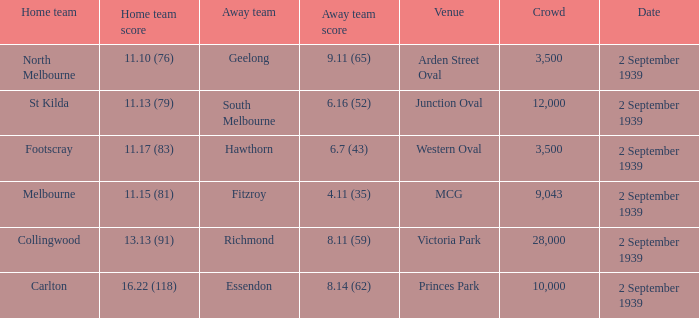Parse the full table. {'header': ['Home team', 'Home team score', 'Away team', 'Away team score', 'Venue', 'Crowd', 'Date'], 'rows': [['North Melbourne', '11.10 (76)', 'Geelong', '9.11 (65)', 'Arden Street Oval', '3,500', '2 September 1939'], ['St Kilda', '11.13 (79)', 'South Melbourne', '6.16 (52)', 'Junction Oval', '12,000', '2 September 1939'], ['Footscray', '11.17 (83)', 'Hawthorn', '6.7 (43)', 'Western Oval', '3,500', '2 September 1939'], ['Melbourne', '11.15 (81)', 'Fitzroy', '4.11 (35)', 'MCG', '9,043', '2 September 1939'], ['Collingwood', '13.13 (91)', 'Richmond', '8.11 (59)', 'Victoria Park', '28,000', '2 September 1939'], ['Carlton', '16.22 (118)', 'Essendon', '8.14 (62)', 'Princes Park', '10,000', '2 September 1939']]} What was the crowd size of the match featuring Hawthorn as the Away team? 3500.0. 